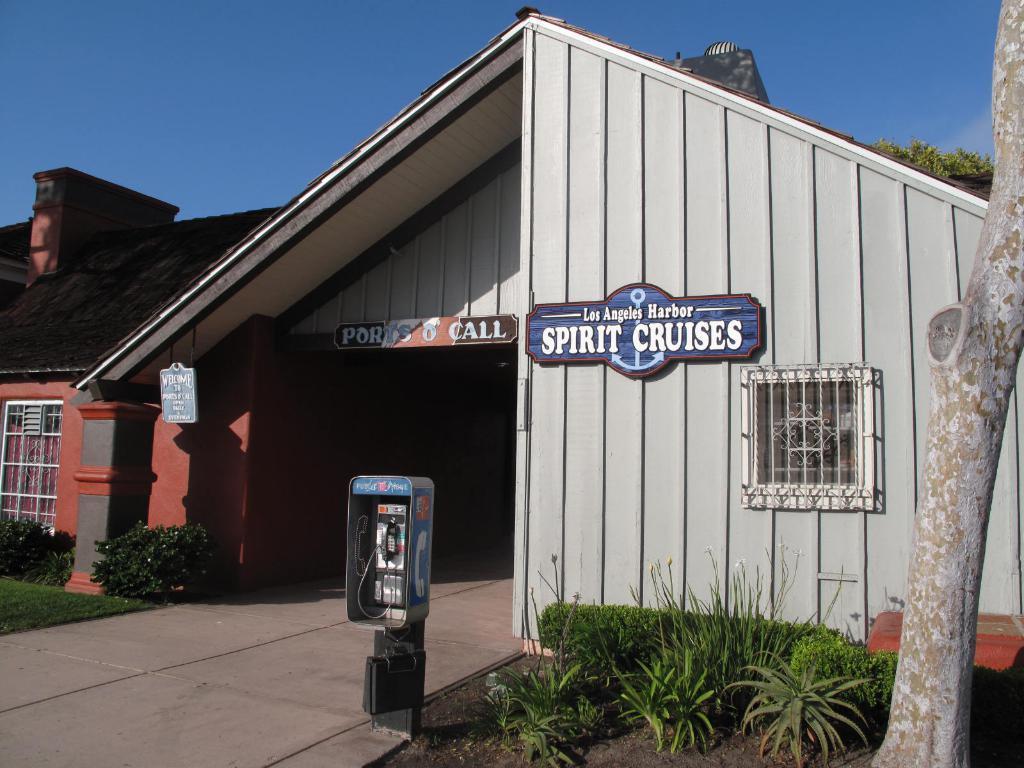Describe this image in one or two sentences. In the picture there is a house in the center of the image and there are plants on the right and left side of the image, there is a vending pole in the center of the image. 